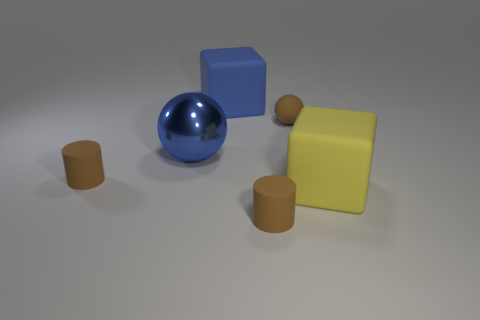Add 2 blue metal balls. How many objects exist? 8 Subtract all rubber cylinders. Subtract all rubber spheres. How many objects are left? 3 Add 3 big blue blocks. How many big blue blocks are left? 4 Add 3 brown rubber things. How many brown rubber things exist? 6 Subtract 0 blue cylinders. How many objects are left? 6 Subtract all purple spheres. Subtract all yellow cylinders. How many spheres are left? 2 